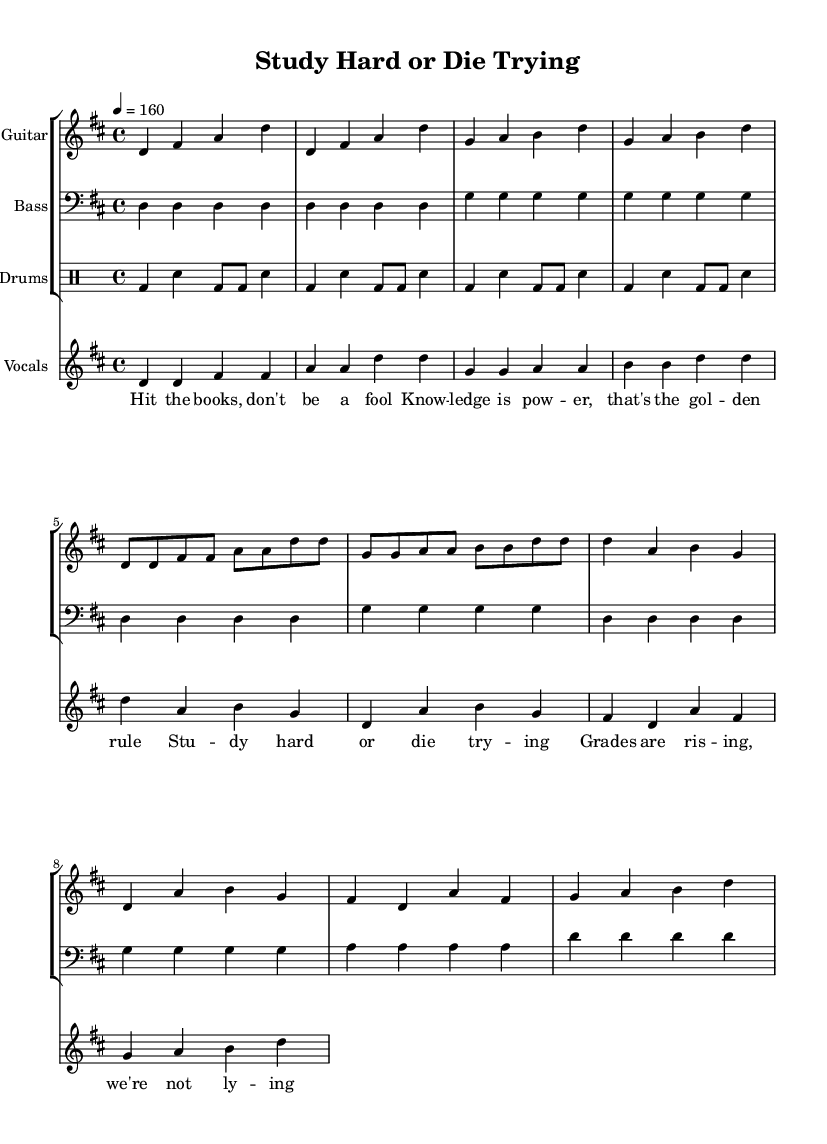What is the key signature of this music? The key signature indicates D major, which has two sharps: F# and C#. This can be determined by identifying the key signature that appears at the beginning of the sheet music.
Answer: D major What is the time signature of the piece? The time signature is 4/4, which means there are four beats in each measure and a quarter note gets one beat. This is typically represented at the start of the score.
Answer: 4/4 What is the tempo marking of the music? The tempo marking is given as a quarter note equals 160 beats per minute, represented in the tempo indication at the beginning of the score.
Answer: 160 How many measures are in the chorus? The chorus consists of four measures, as can be determined by counting the measures from the beginning of the chorus section in the sheet music.
Answer: 4 What type of beat pattern is used in the drums? The drum part features a basic punk beat pattern, characterized by a kick drum on the beats with a snare drum in between, identifiable from the drumming notation in the sheet music.
Answer: Punk beat How many verses are present in the song? The song contains one verse, which can be identified by observing the lyrical structure and the music's layout in the sheet music, as it starts before the chorus.
Answer: 1 What dynamic level can be inferred from the sheet music? The piece is played with high energy typical of punk music, which can be inferred from the tempo and rhythmic intensity, but there are no specific dynamic markings provided.
Answer: High energy 